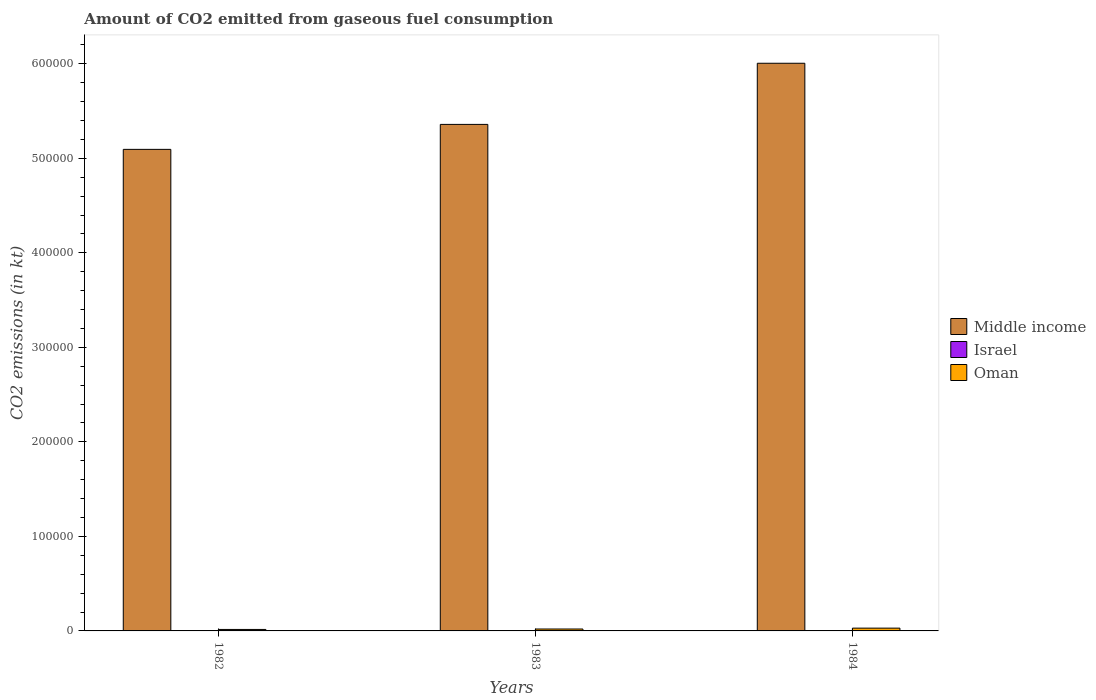Are the number of bars per tick equal to the number of legend labels?
Offer a terse response. Yes. What is the label of the 2nd group of bars from the left?
Ensure brevity in your answer.  1983. What is the amount of CO2 emitted in Middle income in 1982?
Your response must be concise. 5.09e+05. Across all years, what is the maximum amount of CO2 emitted in Oman?
Your response must be concise. 2955.6. Across all years, what is the minimum amount of CO2 emitted in Israel?
Give a very brief answer. 88.01. In which year was the amount of CO2 emitted in Oman minimum?
Your response must be concise. 1982. What is the total amount of CO2 emitted in Middle income in the graph?
Give a very brief answer. 1.65e+06. What is the difference between the amount of CO2 emitted in Oman in 1982 and that in 1984?
Offer a terse response. -1386.13. What is the difference between the amount of CO2 emitted in Oman in 1982 and the amount of CO2 emitted in Israel in 1983?
Ensure brevity in your answer.  1455.8. What is the average amount of CO2 emitted in Oman per year?
Give a very brief answer. 2183.09. In the year 1982, what is the difference between the amount of CO2 emitted in Israel and amount of CO2 emitted in Middle income?
Keep it short and to the point. -5.09e+05. What is the ratio of the amount of CO2 emitted in Middle income in 1983 to that in 1984?
Offer a very short reply. 0.89. Is the amount of CO2 emitted in Oman in 1982 less than that in 1983?
Make the answer very short. Yes. Is the difference between the amount of CO2 emitted in Israel in 1982 and 1983 greater than the difference between the amount of CO2 emitted in Middle income in 1982 and 1983?
Your answer should be very brief. Yes. What is the difference between the highest and the second highest amount of CO2 emitted in Israel?
Give a very brief answer. 22. What is the difference between the highest and the lowest amount of CO2 emitted in Middle income?
Offer a very short reply. 9.11e+04. Is the sum of the amount of CO2 emitted in Oman in 1983 and 1984 greater than the maximum amount of CO2 emitted in Israel across all years?
Provide a succinct answer. Yes. What does the 1st bar from the right in 1983 represents?
Provide a short and direct response. Oman. Is it the case that in every year, the sum of the amount of CO2 emitted in Middle income and amount of CO2 emitted in Oman is greater than the amount of CO2 emitted in Israel?
Keep it short and to the point. Yes. What is the difference between two consecutive major ticks on the Y-axis?
Your response must be concise. 1.00e+05. Are the values on the major ticks of Y-axis written in scientific E-notation?
Give a very brief answer. No. Where does the legend appear in the graph?
Make the answer very short. Center right. How are the legend labels stacked?
Your answer should be very brief. Vertical. What is the title of the graph?
Provide a short and direct response. Amount of CO2 emitted from gaseous fuel consumption. Does "Papua New Guinea" appear as one of the legend labels in the graph?
Your answer should be very brief. No. What is the label or title of the X-axis?
Provide a succinct answer. Years. What is the label or title of the Y-axis?
Your answer should be compact. CO2 emissions (in kt). What is the CO2 emissions (in kt) of Middle income in 1982?
Your answer should be compact. 5.09e+05. What is the CO2 emissions (in kt) in Israel in 1982?
Provide a short and direct response. 135.68. What is the CO2 emissions (in kt) of Oman in 1982?
Your answer should be compact. 1569.48. What is the CO2 emissions (in kt) in Middle income in 1983?
Ensure brevity in your answer.  5.36e+05. What is the CO2 emissions (in kt) of Israel in 1983?
Your answer should be compact. 113.68. What is the CO2 emissions (in kt) in Oman in 1983?
Offer a very short reply. 2024.18. What is the CO2 emissions (in kt) in Middle income in 1984?
Provide a short and direct response. 6.01e+05. What is the CO2 emissions (in kt) of Israel in 1984?
Keep it short and to the point. 88.01. What is the CO2 emissions (in kt) of Oman in 1984?
Your answer should be very brief. 2955.6. Across all years, what is the maximum CO2 emissions (in kt) of Middle income?
Ensure brevity in your answer.  6.01e+05. Across all years, what is the maximum CO2 emissions (in kt) in Israel?
Offer a very short reply. 135.68. Across all years, what is the maximum CO2 emissions (in kt) of Oman?
Offer a terse response. 2955.6. Across all years, what is the minimum CO2 emissions (in kt) of Middle income?
Keep it short and to the point. 5.09e+05. Across all years, what is the minimum CO2 emissions (in kt) of Israel?
Keep it short and to the point. 88.01. Across all years, what is the minimum CO2 emissions (in kt) of Oman?
Keep it short and to the point. 1569.48. What is the total CO2 emissions (in kt) of Middle income in the graph?
Provide a short and direct response. 1.65e+06. What is the total CO2 emissions (in kt) of Israel in the graph?
Keep it short and to the point. 337.36. What is the total CO2 emissions (in kt) in Oman in the graph?
Provide a short and direct response. 6549.26. What is the difference between the CO2 emissions (in kt) of Middle income in 1982 and that in 1983?
Provide a short and direct response. -2.64e+04. What is the difference between the CO2 emissions (in kt) of Israel in 1982 and that in 1983?
Ensure brevity in your answer.  22. What is the difference between the CO2 emissions (in kt) of Oman in 1982 and that in 1983?
Keep it short and to the point. -454.71. What is the difference between the CO2 emissions (in kt) in Middle income in 1982 and that in 1984?
Offer a very short reply. -9.11e+04. What is the difference between the CO2 emissions (in kt) of Israel in 1982 and that in 1984?
Your response must be concise. 47.67. What is the difference between the CO2 emissions (in kt) of Oman in 1982 and that in 1984?
Offer a terse response. -1386.13. What is the difference between the CO2 emissions (in kt) in Middle income in 1983 and that in 1984?
Give a very brief answer. -6.47e+04. What is the difference between the CO2 emissions (in kt) of Israel in 1983 and that in 1984?
Your answer should be very brief. 25.67. What is the difference between the CO2 emissions (in kt) in Oman in 1983 and that in 1984?
Provide a succinct answer. -931.42. What is the difference between the CO2 emissions (in kt) of Middle income in 1982 and the CO2 emissions (in kt) of Israel in 1983?
Give a very brief answer. 5.09e+05. What is the difference between the CO2 emissions (in kt) in Middle income in 1982 and the CO2 emissions (in kt) in Oman in 1983?
Provide a succinct answer. 5.07e+05. What is the difference between the CO2 emissions (in kt) in Israel in 1982 and the CO2 emissions (in kt) in Oman in 1983?
Make the answer very short. -1888.51. What is the difference between the CO2 emissions (in kt) of Middle income in 1982 and the CO2 emissions (in kt) of Israel in 1984?
Make the answer very short. 5.09e+05. What is the difference between the CO2 emissions (in kt) of Middle income in 1982 and the CO2 emissions (in kt) of Oman in 1984?
Give a very brief answer. 5.07e+05. What is the difference between the CO2 emissions (in kt) of Israel in 1982 and the CO2 emissions (in kt) of Oman in 1984?
Your answer should be very brief. -2819.92. What is the difference between the CO2 emissions (in kt) of Middle income in 1983 and the CO2 emissions (in kt) of Israel in 1984?
Your answer should be compact. 5.36e+05. What is the difference between the CO2 emissions (in kt) in Middle income in 1983 and the CO2 emissions (in kt) in Oman in 1984?
Your answer should be very brief. 5.33e+05. What is the difference between the CO2 emissions (in kt) of Israel in 1983 and the CO2 emissions (in kt) of Oman in 1984?
Make the answer very short. -2841.93. What is the average CO2 emissions (in kt) of Middle income per year?
Your response must be concise. 5.49e+05. What is the average CO2 emissions (in kt) in Israel per year?
Give a very brief answer. 112.45. What is the average CO2 emissions (in kt) of Oman per year?
Offer a very short reply. 2183.09. In the year 1982, what is the difference between the CO2 emissions (in kt) in Middle income and CO2 emissions (in kt) in Israel?
Make the answer very short. 5.09e+05. In the year 1982, what is the difference between the CO2 emissions (in kt) in Middle income and CO2 emissions (in kt) in Oman?
Offer a very short reply. 5.08e+05. In the year 1982, what is the difference between the CO2 emissions (in kt) in Israel and CO2 emissions (in kt) in Oman?
Give a very brief answer. -1433.8. In the year 1983, what is the difference between the CO2 emissions (in kt) in Middle income and CO2 emissions (in kt) in Israel?
Provide a succinct answer. 5.36e+05. In the year 1983, what is the difference between the CO2 emissions (in kt) in Middle income and CO2 emissions (in kt) in Oman?
Your response must be concise. 5.34e+05. In the year 1983, what is the difference between the CO2 emissions (in kt) of Israel and CO2 emissions (in kt) of Oman?
Ensure brevity in your answer.  -1910.51. In the year 1984, what is the difference between the CO2 emissions (in kt) of Middle income and CO2 emissions (in kt) of Israel?
Provide a short and direct response. 6.01e+05. In the year 1984, what is the difference between the CO2 emissions (in kt) in Middle income and CO2 emissions (in kt) in Oman?
Provide a succinct answer. 5.98e+05. In the year 1984, what is the difference between the CO2 emissions (in kt) in Israel and CO2 emissions (in kt) in Oman?
Ensure brevity in your answer.  -2867.59. What is the ratio of the CO2 emissions (in kt) of Middle income in 1982 to that in 1983?
Keep it short and to the point. 0.95. What is the ratio of the CO2 emissions (in kt) in Israel in 1982 to that in 1983?
Provide a short and direct response. 1.19. What is the ratio of the CO2 emissions (in kt) of Oman in 1982 to that in 1983?
Provide a short and direct response. 0.78. What is the ratio of the CO2 emissions (in kt) in Middle income in 1982 to that in 1984?
Keep it short and to the point. 0.85. What is the ratio of the CO2 emissions (in kt) in Israel in 1982 to that in 1984?
Your answer should be compact. 1.54. What is the ratio of the CO2 emissions (in kt) of Oman in 1982 to that in 1984?
Provide a short and direct response. 0.53. What is the ratio of the CO2 emissions (in kt) in Middle income in 1983 to that in 1984?
Make the answer very short. 0.89. What is the ratio of the CO2 emissions (in kt) of Israel in 1983 to that in 1984?
Offer a very short reply. 1.29. What is the ratio of the CO2 emissions (in kt) of Oman in 1983 to that in 1984?
Give a very brief answer. 0.68. What is the difference between the highest and the second highest CO2 emissions (in kt) in Middle income?
Offer a terse response. 6.47e+04. What is the difference between the highest and the second highest CO2 emissions (in kt) in Israel?
Keep it short and to the point. 22. What is the difference between the highest and the second highest CO2 emissions (in kt) in Oman?
Give a very brief answer. 931.42. What is the difference between the highest and the lowest CO2 emissions (in kt) of Middle income?
Give a very brief answer. 9.11e+04. What is the difference between the highest and the lowest CO2 emissions (in kt) of Israel?
Provide a short and direct response. 47.67. What is the difference between the highest and the lowest CO2 emissions (in kt) in Oman?
Provide a succinct answer. 1386.13. 